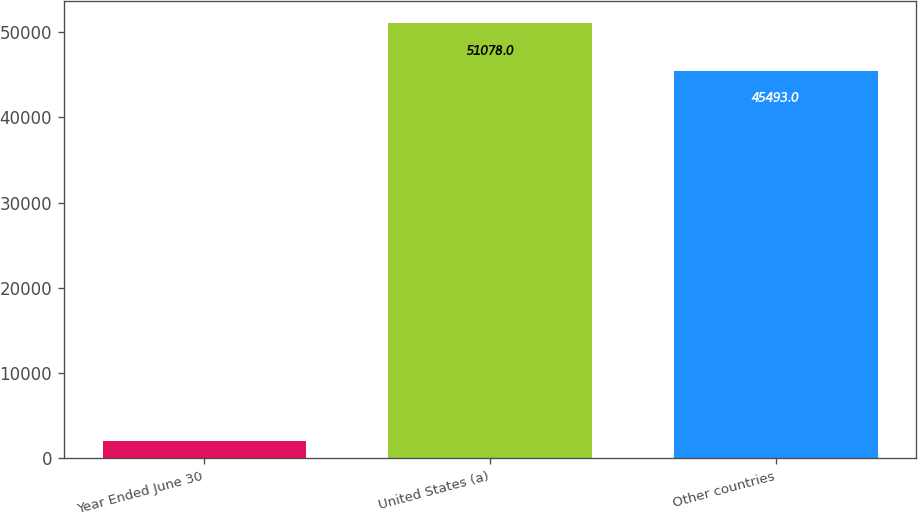<chart> <loc_0><loc_0><loc_500><loc_500><bar_chart><fcel>Year Ended June 30<fcel>United States (a)<fcel>Other countries<nl><fcel>2017<fcel>51078<fcel>45493<nl></chart> 